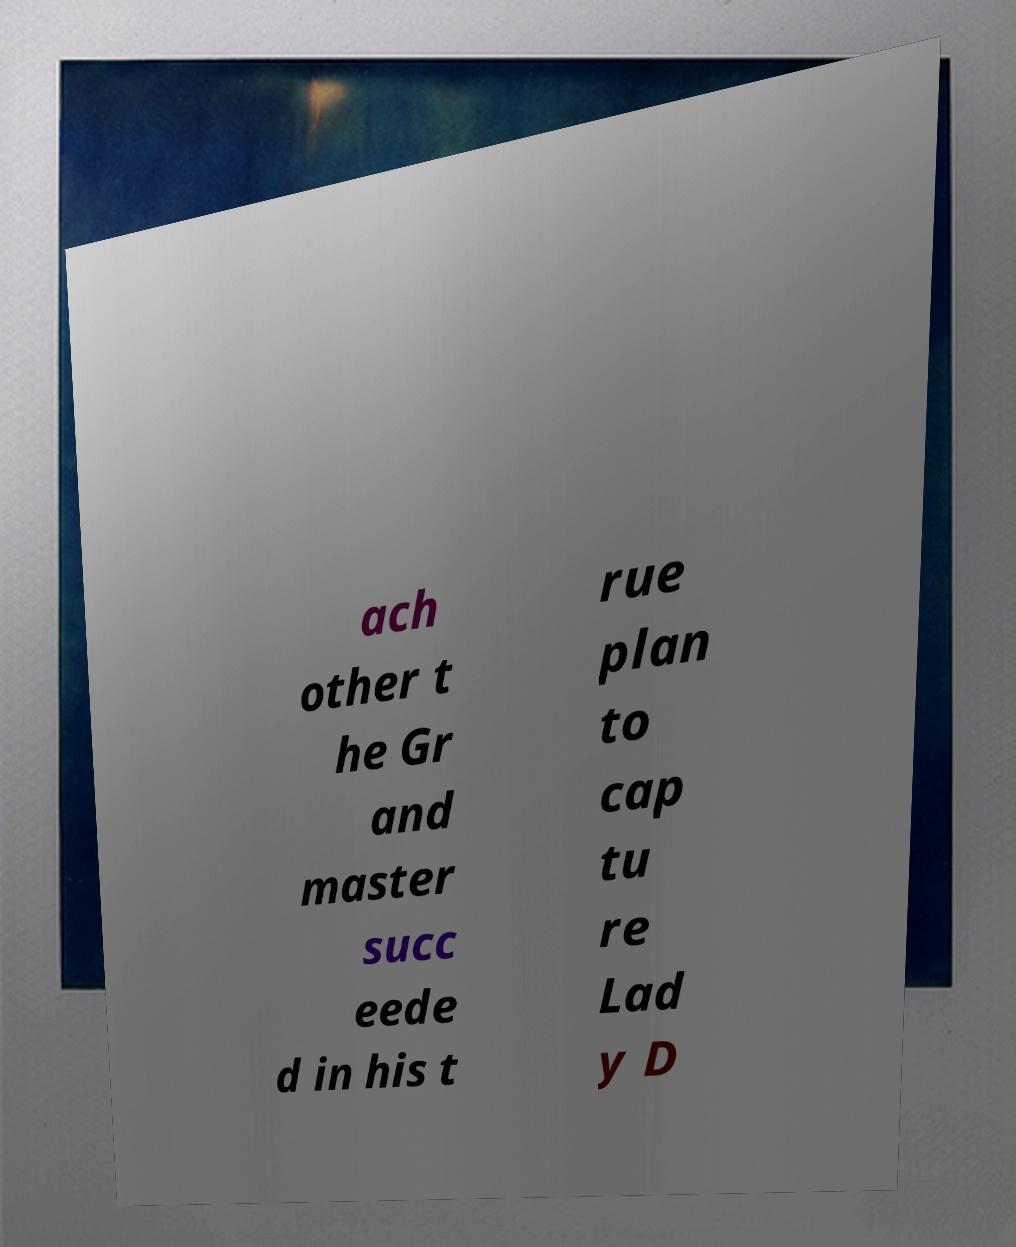Could you assist in decoding the text presented in this image and type it out clearly? ach other t he Gr and master succ eede d in his t rue plan to cap tu re Lad y D 